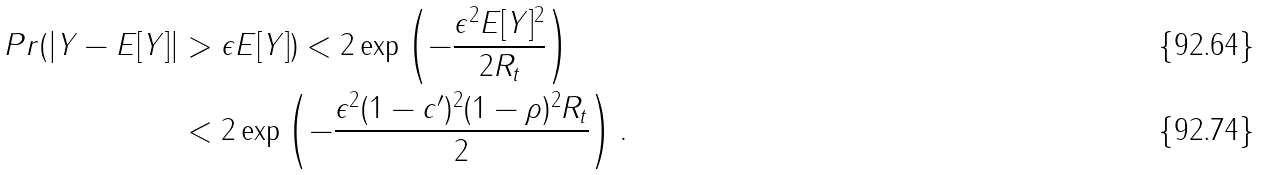<formula> <loc_0><loc_0><loc_500><loc_500>P r ( | Y - E [ Y ] | & > \epsilon E [ Y ] ) < 2 \exp \left ( - \frac { \epsilon ^ { 2 } E [ Y ] ^ { 2 } } { 2 R _ { t } } \right ) \\ & < 2 \exp \left ( - \frac { \epsilon ^ { 2 } ( 1 - c ^ { \prime } ) ^ { 2 } ( 1 - \rho ) ^ { 2 } R _ { t } } { 2 } \right ) .</formula> 